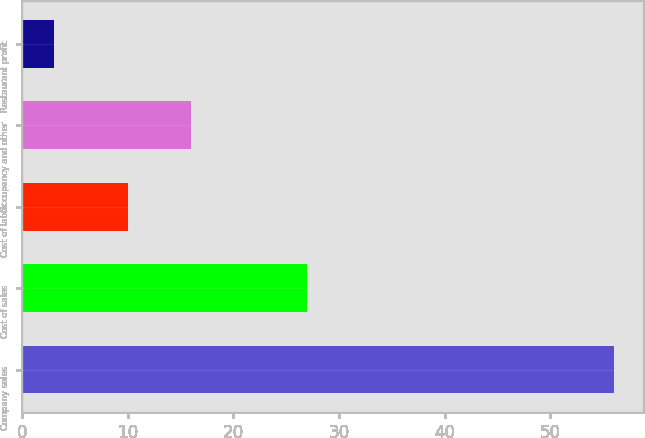Convert chart to OTSL. <chart><loc_0><loc_0><loc_500><loc_500><bar_chart><fcel>Company sales<fcel>Cost of sales<fcel>Cost of labor<fcel>Occupancy and other<fcel>Restaurant profit<nl><fcel>56<fcel>27<fcel>10<fcel>16<fcel>3<nl></chart> 